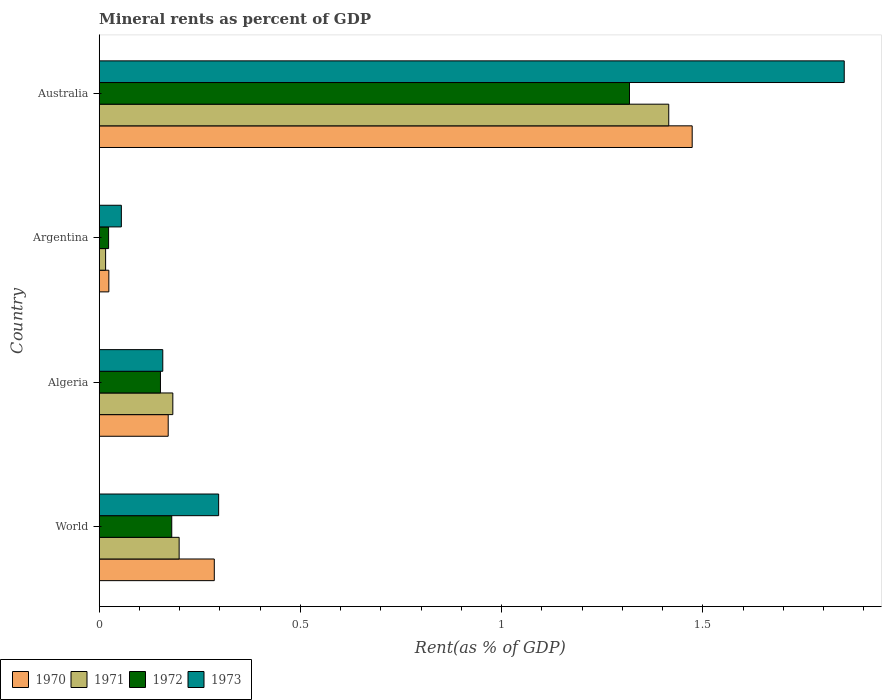Are the number of bars on each tick of the Y-axis equal?
Offer a terse response. Yes. How many bars are there on the 2nd tick from the top?
Provide a succinct answer. 4. How many bars are there on the 1st tick from the bottom?
Your answer should be very brief. 4. What is the label of the 3rd group of bars from the top?
Ensure brevity in your answer.  Algeria. In how many cases, is the number of bars for a given country not equal to the number of legend labels?
Ensure brevity in your answer.  0. What is the mineral rent in 1972 in World?
Your response must be concise. 0.18. Across all countries, what is the maximum mineral rent in 1971?
Your answer should be very brief. 1.42. Across all countries, what is the minimum mineral rent in 1972?
Your response must be concise. 0.02. In which country was the mineral rent in 1971 minimum?
Your response must be concise. Argentina. What is the total mineral rent in 1972 in the graph?
Make the answer very short. 1.67. What is the difference between the mineral rent in 1971 in Algeria and that in Argentina?
Provide a succinct answer. 0.17. What is the difference between the mineral rent in 1971 in World and the mineral rent in 1973 in Algeria?
Provide a short and direct response. 0.04. What is the average mineral rent in 1971 per country?
Ensure brevity in your answer.  0.45. What is the difference between the mineral rent in 1970 and mineral rent in 1971 in Australia?
Provide a succinct answer. 0.06. What is the ratio of the mineral rent in 1973 in Algeria to that in Argentina?
Provide a succinct answer. 2.87. Is the mineral rent in 1973 in Argentina less than that in Australia?
Your answer should be very brief. Yes. Is the difference between the mineral rent in 1970 in Algeria and Australia greater than the difference between the mineral rent in 1971 in Algeria and Australia?
Ensure brevity in your answer.  No. What is the difference between the highest and the second highest mineral rent in 1970?
Your answer should be compact. 1.19. What is the difference between the highest and the lowest mineral rent in 1973?
Your answer should be very brief. 1.8. Is the sum of the mineral rent in 1973 in Argentina and World greater than the maximum mineral rent in 1971 across all countries?
Offer a terse response. No. Is it the case that in every country, the sum of the mineral rent in 1972 and mineral rent in 1970 is greater than the sum of mineral rent in 1973 and mineral rent in 1971?
Keep it short and to the point. No. What does the 4th bar from the top in Algeria represents?
Provide a succinct answer. 1970. What does the 2nd bar from the bottom in World represents?
Make the answer very short. 1971. Is it the case that in every country, the sum of the mineral rent in 1970 and mineral rent in 1971 is greater than the mineral rent in 1973?
Ensure brevity in your answer.  No. How many bars are there?
Give a very brief answer. 16. How many countries are there in the graph?
Your answer should be compact. 4. What is the difference between two consecutive major ticks on the X-axis?
Give a very brief answer. 0.5. Are the values on the major ticks of X-axis written in scientific E-notation?
Keep it short and to the point. No. Does the graph contain any zero values?
Your answer should be very brief. No. Does the graph contain grids?
Your response must be concise. No. Where does the legend appear in the graph?
Your answer should be compact. Bottom left. How are the legend labels stacked?
Provide a short and direct response. Horizontal. What is the title of the graph?
Give a very brief answer. Mineral rents as percent of GDP. What is the label or title of the X-axis?
Provide a short and direct response. Rent(as % of GDP). What is the Rent(as % of GDP) in 1970 in World?
Your answer should be very brief. 0.29. What is the Rent(as % of GDP) in 1971 in World?
Your response must be concise. 0.2. What is the Rent(as % of GDP) in 1972 in World?
Your answer should be very brief. 0.18. What is the Rent(as % of GDP) of 1973 in World?
Your response must be concise. 0.3. What is the Rent(as % of GDP) in 1970 in Algeria?
Your answer should be compact. 0.17. What is the Rent(as % of GDP) of 1971 in Algeria?
Offer a terse response. 0.18. What is the Rent(as % of GDP) of 1972 in Algeria?
Your answer should be compact. 0.15. What is the Rent(as % of GDP) in 1973 in Algeria?
Offer a terse response. 0.16. What is the Rent(as % of GDP) of 1970 in Argentina?
Give a very brief answer. 0.02. What is the Rent(as % of GDP) of 1971 in Argentina?
Offer a terse response. 0.02. What is the Rent(as % of GDP) in 1972 in Argentina?
Provide a succinct answer. 0.02. What is the Rent(as % of GDP) of 1973 in Argentina?
Your answer should be very brief. 0.06. What is the Rent(as % of GDP) in 1970 in Australia?
Provide a succinct answer. 1.47. What is the Rent(as % of GDP) of 1971 in Australia?
Make the answer very short. 1.42. What is the Rent(as % of GDP) in 1972 in Australia?
Your response must be concise. 1.32. What is the Rent(as % of GDP) of 1973 in Australia?
Offer a terse response. 1.85. Across all countries, what is the maximum Rent(as % of GDP) of 1970?
Your answer should be compact. 1.47. Across all countries, what is the maximum Rent(as % of GDP) in 1971?
Offer a terse response. 1.42. Across all countries, what is the maximum Rent(as % of GDP) in 1972?
Provide a succinct answer. 1.32. Across all countries, what is the maximum Rent(as % of GDP) of 1973?
Ensure brevity in your answer.  1.85. Across all countries, what is the minimum Rent(as % of GDP) of 1970?
Provide a succinct answer. 0.02. Across all countries, what is the minimum Rent(as % of GDP) in 1971?
Keep it short and to the point. 0.02. Across all countries, what is the minimum Rent(as % of GDP) in 1972?
Offer a very short reply. 0.02. Across all countries, what is the minimum Rent(as % of GDP) of 1973?
Offer a terse response. 0.06. What is the total Rent(as % of GDP) in 1970 in the graph?
Keep it short and to the point. 1.95. What is the total Rent(as % of GDP) in 1971 in the graph?
Keep it short and to the point. 1.81. What is the total Rent(as % of GDP) in 1972 in the graph?
Make the answer very short. 1.67. What is the total Rent(as % of GDP) of 1973 in the graph?
Your response must be concise. 2.36. What is the difference between the Rent(as % of GDP) of 1970 in World and that in Algeria?
Offer a very short reply. 0.11. What is the difference between the Rent(as % of GDP) of 1971 in World and that in Algeria?
Provide a succinct answer. 0.02. What is the difference between the Rent(as % of GDP) of 1972 in World and that in Algeria?
Your answer should be very brief. 0.03. What is the difference between the Rent(as % of GDP) in 1973 in World and that in Algeria?
Your answer should be compact. 0.14. What is the difference between the Rent(as % of GDP) in 1970 in World and that in Argentina?
Offer a very short reply. 0.26. What is the difference between the Rent(as % of GDP) of 1971 in World and that in Argentina?
Offer a terse response. 0.18. What is the difference between the Rent(as % of GDP) of 1972 in World and that in Argentina?
Give a very brief answer. 0.16. What is the difference between the Rent(as % of GDP) in 1973 in World and that in Argentina?
Offer a terse response. 0.24. What is the difference between the Rent(as % of GDP) of 1970 in World and that in Australia?
Make the answer very short. -1.19. What is the difference between the Rent(as % of GDP) of 1971 in World and that in Australia?
Your answer should be compact. -1.22. What is the difference between the Rent(as % of GDP) in 1972 in World and that in Australia?
Offer a very short reply. -1.14. What is the difference between the Rent(as % of GDP) of 1973 in World and that in Australia?
Your response must be concise. -1.55. What is the difference between the Rent(as % of GDP) of 1970 in Algeria and that in Argentina?
Provide a short and direct response. 0.15. What is the difference between the Rent(as % of GDP) in 1971 in Algeria and that in Argentina?
Ensure brevity in your answer.  0.17. What is the difference between the Rent(as % of GDP) of 1972 in Algeria and that in Argentina?
Make the answer very short. 0.13. What is the difference between the Rent(as % of GDP) of 1973 in Algeria and that in Argentina?
Make the answer very short. 0.1. What is the difference between the Rent(as % of GDP) in 1970 in Algeria and that in Australia?
Your response must be concise. -1.3. What is the difference between the Rent(as % of GDP) of 1971 in Algeria and that in Australia?
Make the answer very short. -1.23. What is the difference between the Rent(as % of GDP) in 1972 in Algeria and that in Australia?
Your answer should be very brief. -1.17. What is the difference between the Rent(as % of GDP) in 1973 in Algeria and that in Australia?
Offer a very short reply. -1.69. What is the difference between the Rent(as % of GDP) of 1970 in Argentina and that in Australia?
Provide a short and direct response. -1.45. What is the difference between the Rent(as % of GDP) of 1971 in Argentina and that in Australia?
Provide a succinct answer. -1.4. What is the difference between the Rent(as % of GDP) of 1972 in Argentina and that in Australia?
Provide a succinct answer. -1.29. What is the difference between the Rent(as % of GDP) in 1973 in Argentina and that in Australia?
Your answer should be very brief. -1.8. What is the difference between the Rent(as % of GDP) in 1970 in World and the Rent(as % of GDP) in 1971 in Algeria?
Keep it short and to the point. 0.1. What is the difference between the Rent(as % of GDP) in 1970 in World and the Rent(as % of GDP) in 1972 in Algeria?
Offer a very short reply. 0.13. What is the difference between the Rent(as % of GDP) of 1970 in World and the Rent(as % of GDP) of 1973 in Algeria?
Give a very brief answer. 0.13. What is the difference between the Rent(as % of GDP) of 1971 in World and the Rent(as % of GDP) of 1972 in Algeria?
Provide a short and direct response. 0.05. What is the difference between the Rent(as % of GDP) of 1971 in World and the Rent(as % of GDP) of 1973 in Algeria?
Ensure brevity in your answer.  0.04. What is the difference between the Rent(as % of GDP) in 1972 in World and the Rent(as % of GDP) in 1973 in Algeria?
Ensure brevity in your answer.  0.02. What is the difference between the Rent(as % of GDP) in 1970 in World and the Rent(as % of GDP) in 1971 in Argentina?
Offer a terse response. 0.27. What is the difference between the Rent(as % of GDP) of 1970 in World and the Rent(as % of GDP) of 1972 in Argentina?
Make the answer very short. 0.26. What is the difference between the Rent(as % of GDP) in 1970 in World and the Rent(as % of GDP) in 1973 in Argentina?
Your answer should be compact. 0.23. What is the difference between the Rent(as % of GDP) in 1971 in World and the Rent(as % of GDP) in 1972 in Argentina?
Your response must be concise. 0.18. What is the difference between the Rent(as % of GDP) in 1971 in World and the Rent(as % of GDP) in 1973 in Argentina?
Provide a succinct answer. 0.14. What is the difference between the Rent(as % of GDP) of 1972 in World and the Rent(as % of GDP) of 1973 in Argentina?
Provide a succinct answer. 0.13. What is the difference between the Rent(as % of GDP) in 1970 in World and the Rent(as % of GDP) in 1971 in Australia?
Your answer should be compact. -1.13. What is the difference between the Rent(as % of GDP) of 1970 in World and the Rent(as % of GDP) of 1972 in Australia?
Offer a very short reply. -1.03. What is the difference between the Rent(as % of GDP) in 1970 in World and the Rent(as % of GDP) in 1973 in Australia?
Your answer should be very brief. -1.57. What is the difference between the Rent(as % of GDP) in 1971 in World and the Rent(as % of GDP) in 1972 in Australia?
Keep it short and to the point. -1.12. What is the difference between the Rent(as % of GDP) in 1971 in World and the Rent(as % of GDP) in 1973 in Australia?
Provide a succinct answer. -1.65. What is the difference between the Rent(as % of GDP) of 1972 in World and the Rent(as % of GDP) of 1973 in Australia?
Provide a short and direct response. -1.67. What is the difference between the Rent(as % of GDP) in 1970 in Algeria and the Rent(as % of GDP) in 1971 in Argentina?
Your response must be concise. 0.16. What is the difference between the Rent(as % of GDP) in 1970 in Algeria and the Rent(as % of GDP) in 1972 in Argentina?
Provide a succinct answer. 0.15. What is the difference between the Rent(as % of GDP) in 1970 in Algeria and the Rent(as % of GDP) in 1973 in Argentina?
Provide a succinct answer. 0.12. What is the difference between the Rent(as % of GDP) of 1971 in Algeria and the Rent(as % of GDP) of 1972 in Argentina?
Your response must be concise. 0.16. What is the difference between the Rent(as % of GDP) of 1971 in Algeria and the Rent(as % of GDP) of 1973 in Argentina?
Your response must be concise. 0.13. What is the difference between the Rent(as % of GDP) of 1972 in Algeria and the Rent(as % of GDP) of 1973 in Argentina?
Provide a succinct answer. 0.1. What is the difference between the Rent(as % of GDP) of 1970 in Algeria and the Rent(as % of GDP) of 1971 in Australia?
Provide a short and direct response. -1.24. What is the difference between the Rent(as % of GDP) in 1970 in Algeria and the Rent(as % of GDP) in 1972 in Australia?
Your answer should be compact. -1.15. What is the difference between the Rent(as % of GDP) of 1970 in Algeria and the Rent(as % of GDP) of 1973 in Australia?
Keep it short and to the point. -1.68. What is the difference between the Rent(as % of GDP) in 1971 in Algeria and the Rent(as % of GDP) in 1972 in Australia?
Provide a short and direct response. -1.13. What is the difference between the Rent(as % of GDP) of 1971 in Algeria and the Rent(as % of GDP) of 1973 in Australia?
Keep it short and to the point. -1.67. What is the difference between the Rent(as % of GDP) in 1972 in Algeria and the Rent(as % of GDP) in 1973 in Australia?
Keep it short and to the point. -1.7. What is the difference between the Rent(as % of GDP) of 1970 in Argentina and the Rent(as % of GDP) of 1971 in Australia?
Offer a very short reply. -1.39. What is the difference between the Rent(as % of GDP) of 1970 in Argentina and the Rent(as % of GDP) of 1972 in Australia?
Give a very brief answer. -1.29. What is the difference between the Rent(as % of GDP) in 1970 in Argentina and the Rent(as % of GDP) in 1973 in Australia?
Give a very brief answer. -1.83. What is the difference between the Rent(as % of GDP) of 1971 in Argentina and the Rent(as % of GDP) of 1972 in Australia?
Your answer should be very brief. -1.3. What is the difference between the Rent(as % of GDP) in 1971 in Argentina and the Rent(as % of GDP) in 1973 in Australia?
Keep it short and to the point. -1.84. What is the difference between the Rent(as % of GDP) of 1972 in Argentina and the Rent(as % of GDP) of 1973 in Australia?
Your answer should be very brief. -1.83. What is the average Rent(as % of GDP) of 1970 per country?
Your answer should be very brief. 0.49. What is the average Rent(as % of GDP) in 1971 per country?
Keep it short and to the point. 0.45. What is the average Rent(as % of GDP) of 1972 per country?
Your answer should be compact. 0.42. What is the average Rent(as % of GDP) of 1973 per country?
Your answer should be very brief. 0.59. What is the difference between the Rent(as % of GDP) in 1970 and Rent(as % of GDP) in 1971 in World?
Offer a terse response. 0.09. What is the difference between the Rent(as % of GDP) of 1970 and Rent(as % of GDP) of 1972 in World?
Offer a very short reply. 0.11. What is the difference between the Rent(as % of GDP) in 1970 and Rent(as % of GDP) in 1973 in World?
Your response must be concise. -0.01. What is the difference between the Rent(as % of GDP) in 1971 and Rent(as % of GDP) in 1972 in World?
Give a very brief answer. 0.02. What is the difference between the Rent(as % of GDP) of 1971 and Rent(as % of GDP) of 1973 in World?
Your response must be concise. -0.1. What is the difference between the Rent(as % of GDP) in 1972 and Rent(as % of GDP) in 1973 in World?
Your response must be concise. -0.12. What is the difference between the Rent(as % of GDP) in 1970 and Rent(as % of GDP) in 1971 in Algeria?
Offer a terse response. -0.01. What is the difference between the Rent(as % of GDP) in 1970 and Rent(as % of GDP) in 1972 in Algeria?
Provide a short and direct response. 0.02. What is the difference between the Rent(as % of GDP) of 1970 and Rent(as % of GDP) of 1973 in Algeria?
Give a very brief answer. 0.01. What is the difference between the Rent(as % of GDP) in 1971 and Rent(as % of GDP) in 1972 in Algeria?
Offer a terse response. 0.03. What is the difference between the Rent(as % of GDP) in 1971 and Rent(as % of GDP) in 1973 in Algeria?
Keep it short and to the point. 0.03. What is the difference between the Rent(as % of GDP) in 1972 and Rent(as % of GDP) in 1973 in Algeria?
Offer a terse response. -0.01. What is the difference between the Rent(as % of GDP) in 1970 and Rent(as % of GDP) in 1971 in Argentina?
Your response must be concise. 0.01. What is the difference between the Rent(as % of GDP) of 1970 and Rent(as % of GDP) of 1972 in Argentina?
Offer a terse response. 0. What is the difference between the Rent(as % of GDP) in 1970 and Rent(as % of GDP) in 1973 in Argentina?
Keep it short and to the point. -0.03. What is the difference between the Rent(as % of GDP) in 1971 and Rent(as % of GDP) in 1972 in Argentina?
Offer a terse response. -0.01. What is the difference between the Rent(as % of GDP) in 1971 and Rent(as % of GDP) in 1973 in Argentina?
Give a very brief answer. -0.04. What is the difference between the Rent(as % of GDP) of 1972 and Rent(as % of GDP) of 1973 in Argentina?
Provide a succinct answer. -0.03. What is the difference between the Rent(as % of GDP) of 1970 and Rent(as % of GDP) of 1971 in Australia?
Give a very brief answer. 0.06. What is the difference between the Rent(as % of GDP) in 1970 and Rent(as % of GDP) in 1972 in Australia?
Provide a succinct answer. 0.16. What is the difference between the Rent(as % of GDP) of 1970 and Rent(as % of GDP) of 1973 in Australia?
Provide a short and direct response. -0.38. What is the difference between the Rent(as % of GDP) of 1971 and Rent(as % of GDP) of 1972 in Australia?
Offer a very short reply. 0.1. What is the difference between the Rent(as % of GDP) of 1971 and Rent(as % of GDP) of 1973 in Australia?
Make the answer very short. -0.44. What is the difference between the Rent(as % of GDP) in 1972 and Rent(as % of GDP) in 1973 in Australia?
Ensure brevity in your answer.  -0.53. What is the ratio of the Rent(as % of GDP) in 1970 in World to that in Algeria?
Keep it short and to the point. 1.67. What is the ratio of the Rent(as % of GDP) of 1971 in World to that in Algeria?
Your answer should be compact. 1.09. What is the ratio of the Rent(as % of GDP) in 1972 in World to that in Algeria?
Offer a very short reply. 1.18. What is the ratio of the Rent(as % of GDP) in 1973 in World to that in Algeria?
Provide a short and direct response. 1.88. What is the ratio of the Rent(as % of GDP) of 1970 in World to that in Argentina?
Give a very brief answer. 11.96. What is the ratio of the Rent(as % of GDP) in 1971 in World to that in Argentina?
Your answer should be very brief. 12.49. What is the ratio of the Rent(as % of GDP) in 1972 in World to that in Argentina?
Keep it short and to the point. 7.73. What is the ratio of the Rent(as % of GDP) of 1973 in World to that in Argentina?
Offer a very short reply. 5.4. What is the ratio of the Rent(as % of GDP) in 1970 in World to that in Australia?
Give a very brief answer. 0.19. What is the ratio of the Rent(as % of GDP) of 1971 in World to that in Australia?
Offer a very short reply. 0.14. What is the ratio of the Rent(as % of GDP) of 1972 in World to that in Australia?
Your response must be concise. 0.14. What is the ratio of the Rent(as % of GDP) in 1973 in World to that in Australia?
Make the answer very short. 0.16. What is the ratio of the Rent(as % of GDP) of 1970 in Algeria to that in Argentina?
Make the answer very short. 7.17. What is the ratio of the Rent(as % of GDP) of 1971 in Algeria to that in Argentina?
Ensure brevity in your answer.  11.5. What is the ratio of the Rent(as % of GDP) of 1972 in Algeria to that in Argentina?
Keep it short and to the point. 6.53. What is the ratio of the Rent(as % of GDP) in 1973 in Algeria to that in Argentina?
Your response must be concise. 2.87. What is the ratio of the Rent(as % of GDP) of 1970 in Algeria to that in Australia?
Your answer should be very brief. 0.12. What is the ratio of the Rent(as % of GDP) of 1971 in Algeria to that in Australia?
Give a very brief answer. 0.13. What is the ratio of the Rent(as % of GDP) of 1972 in Algeria to that in Australia?
Provide a short and direct response. 0.12. What is the ratio of the Rent(as % of GDP) in 1973 in Algeria to that in Australia?
Your response must be concise. 0.09. What is the ratio of the Rent(as % of GDP) of 1970 in Argentina to that in Australia?
Provide a short and direct response. 0.02. What is the ratio of the Rent(as % of GDP) in 1971 in Argentina to that in Australia?
Your response must be concise. 0.01. What is the ratio of the Rent(as % of GDP) in 1972 in Argentina to that in Australia?
Keep it short and to the point. 0.02. What is the ratio of the Rent(as % of GDP) in 1973 in Argentina to that in Australia?
Give a very brief answer. 0.03. What is the difference between the highest and the second highest Rent(as % of GDP) of 1970?
Your answer should be very brief. 1.19. What is the difference between the highest and the second highest Rent(as % of GDP) of 1971?
Provide a succinct answer. 1.22. What is the difference between the highest and the second highest Rent(as % of GDP) of 1972?
Ensure brevity in your answer.  1.14. What is the difference between the highest and the second highest Rent(as % of GDP) in 1973?
Ensure brevity in your answer.  1.55. What is the difference between the highest and the lowest Rent(as % of GDP) of 1970?
Give a very brief answer. 1.45. What is the difference between the highest and the lowest Rent(as % of GDP) in 1971?
Your answer should be very brief. 1.4. What is the difference between the highest and the lowest Rent(as % of GDP) of 1972?
Your answer should be very brief. 1.29. What is the difference between the highest and the lowest Rent(as % of GDP) of 1973?
Your answer should be very brief. 1.8. 